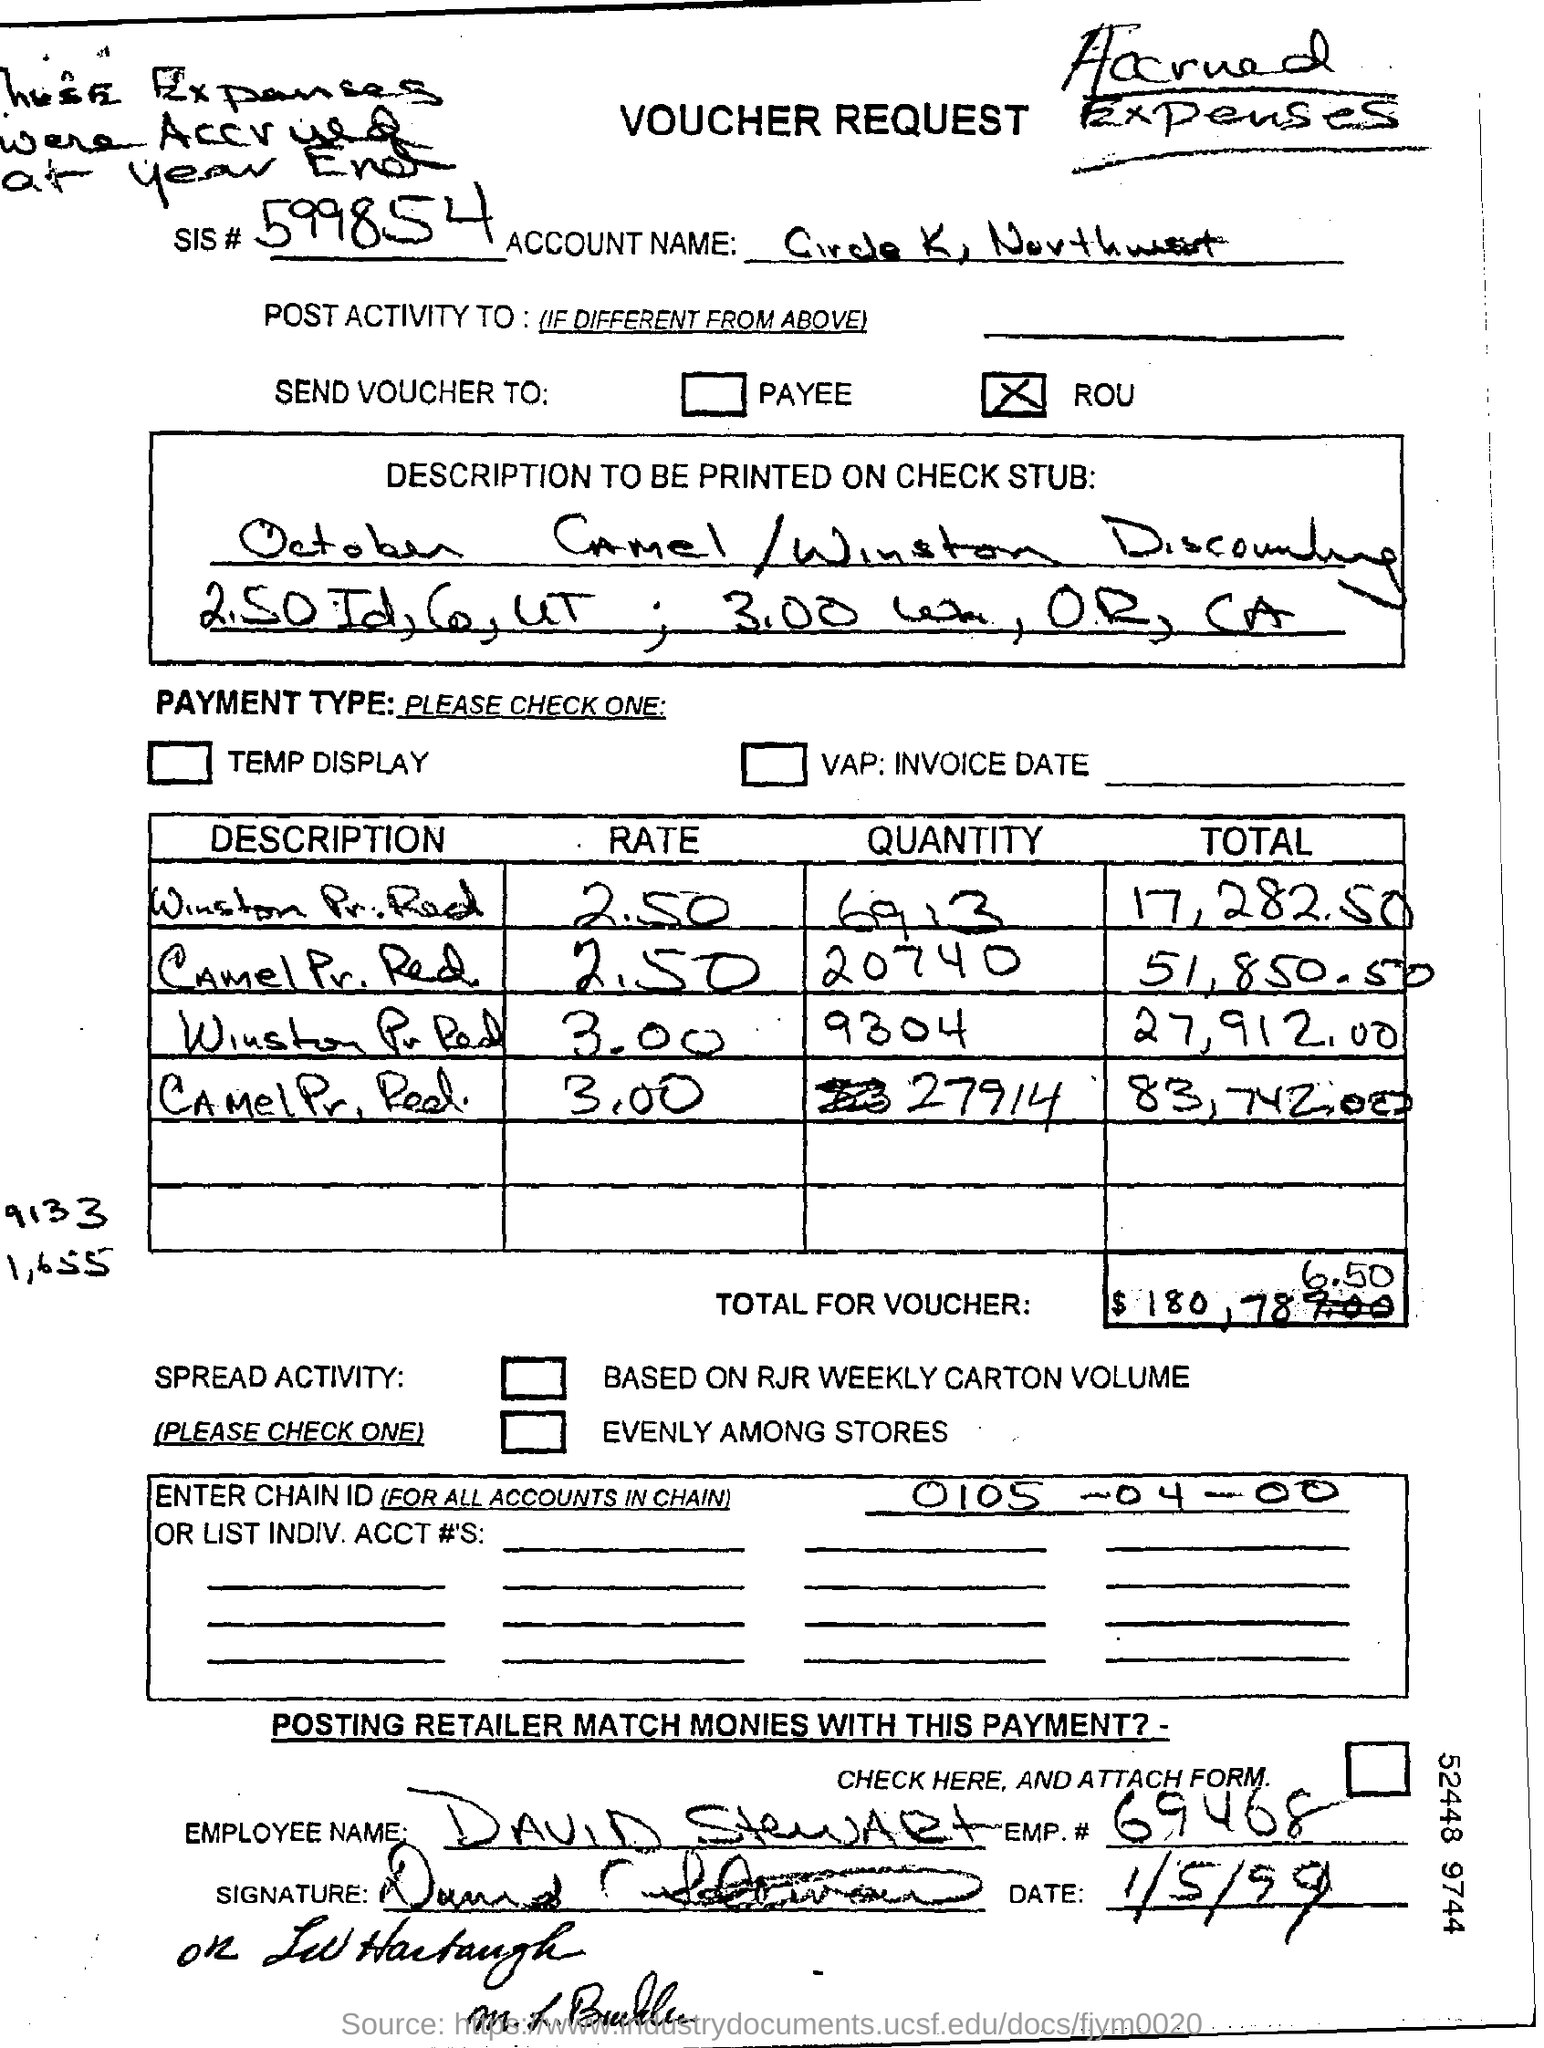Identify some key points in this picture. The name of the employee is David Stewart. What is the code for the SIS#? 599854... 